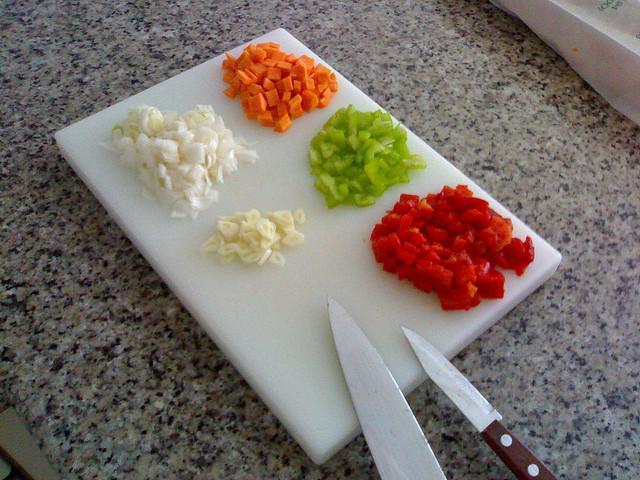How many knives are there?
Give a very brief answer. 2. How many skis is the boy holding?
Give a very brief answer. 0. 